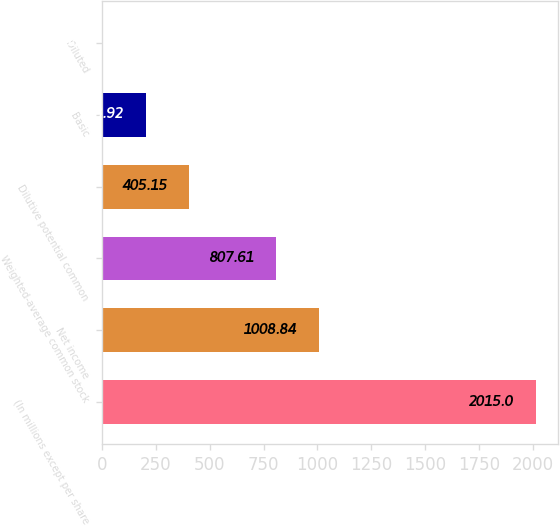Convert chart to OTSL. <chart><loc_0><loc_0><loc_500><loc_500><bar_chart><fcel>(In millions except per share<fcel>Net income<fcel>Weighted-average common stock<fcel>Dilutive potential common<fcel>Basic<fcel>Diluted<nl><fcel>2015<fcel>1008.84<fcel>807.61<fcel>405.15<fcel>203.92<fcel>2.69<nl></chart> 